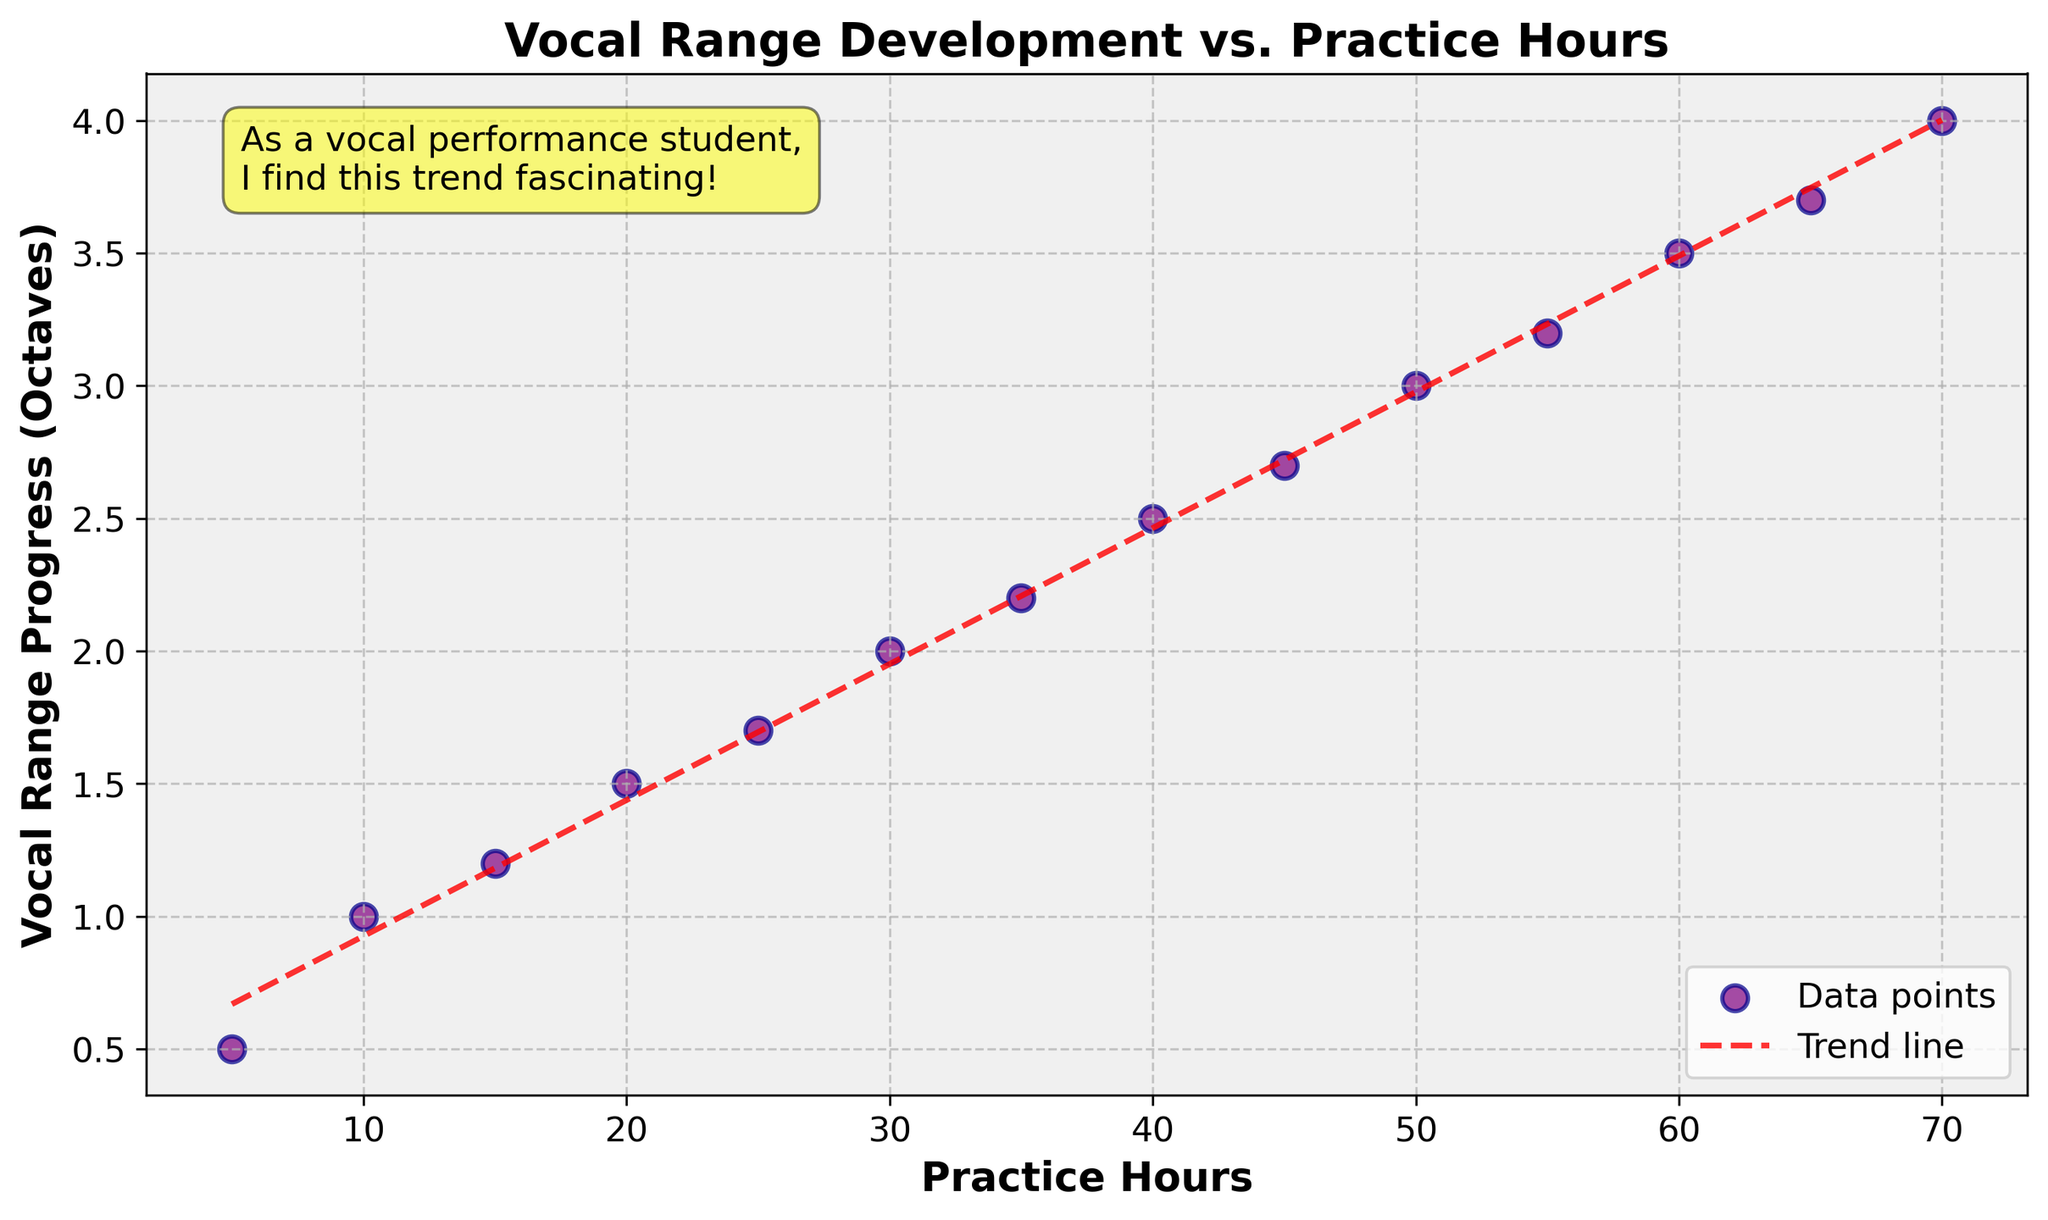How many data points are in the scatter plot? Each dot in the scatter plot represents a data point. By counting these dots, we find there are 14 data points.
Answer: 14 What is the title of the figure? The title of the figure is located at the top of the plot. It reads "Vocal Range Development vs. Practice Hours".
Answer: Vocal Range Development vs. Practice Hours What is the y-axis label, and what does it represent? The y-axis label is "Vocal Range Progress (Octaves)", which represents the increase in vocal range, measured in octaves, achieved by the music students.
Answer: Vocal Range Progress (Octaves) What trend does the trend line suggest? The trend line, which is red and dashed, generally trends upward, suggesting a positive correlation between practice hours and vocal range progress.
Answer: Positive correlation between practice hours and vocal range progress How much vocal range progress is achieved with 35 practice hours? To find this, locate the point on the scatter plot where Practice Hours is 35 and look at its corresponding Vocal Range Progress value on the y-axis, which is 2.2 octaves.
Answer: 2.2 octaves Compare the vocal range progress at 10 practice hours with that at 60 practice hours. Which one is greater and by how much? Locate the points for 10 and 60 practice hours on the scatter plot. For 10 hours, the progress is 1.0 octave. For 60 hours, the progress is 3.5 octaves. The difference is 3.5 - 1.0 = 2.5 octaves.
Answer: 60 practice hours by 2.5 octaves How does the scatter plot annotate the insight about the trend? The scatter plot has a text annotation in the upper left, within a yellow box, stating, "As a vocal performance student, I find this trend fascinating!"
Answer: Text annotation in a yellow box What is the approximate increase in vocal range progress from 25 to 50 practice hours? At 25 practice hours, the vocal range progress is around 1.7 octaves; at 50 practice hours, it's about 3.0 octaves. The increase is 3.0 - 1.7 = 1.3 octaves.
Answer: 1.3 octaves Is there any grid in the plot? What does it look like? Yes, the plot has a grid. It is made up of dashed lines, which are lightly colored, appearing behind the data points.
Answer: Dashed lines grid What does the color purple represent in the scatter plot? In the scatter plot, the color purple is used for the data points, indicating the individual measurements of practice hours and corresponding vocal range progress for music students.
Answer: Data points 